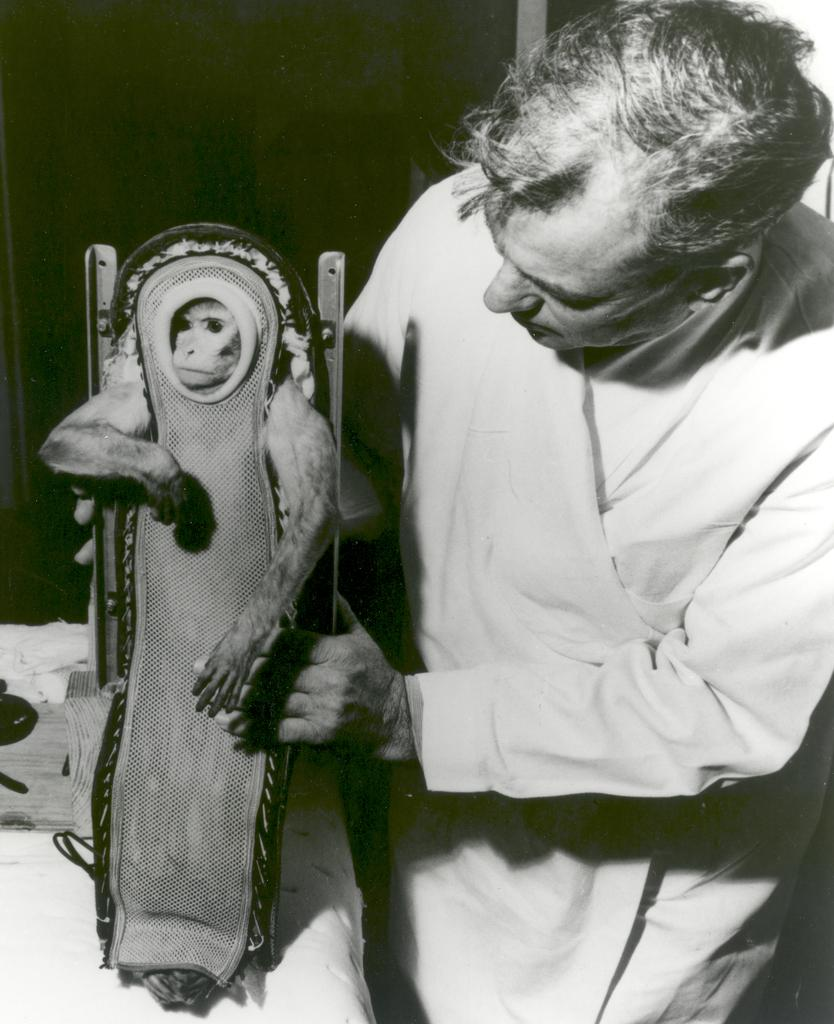What is the color scheme of the image? The image is black and white. What is the man in the image doing? The man is holding a monkey. What can be seen on the table in the image? There are items on a table. What is the color of the area behind the man? The area behind the man is black in color. Can you see the sea in the image? No, there is no sea visible in the image. What type of recess is present in the image? There is no recess present in the image. 